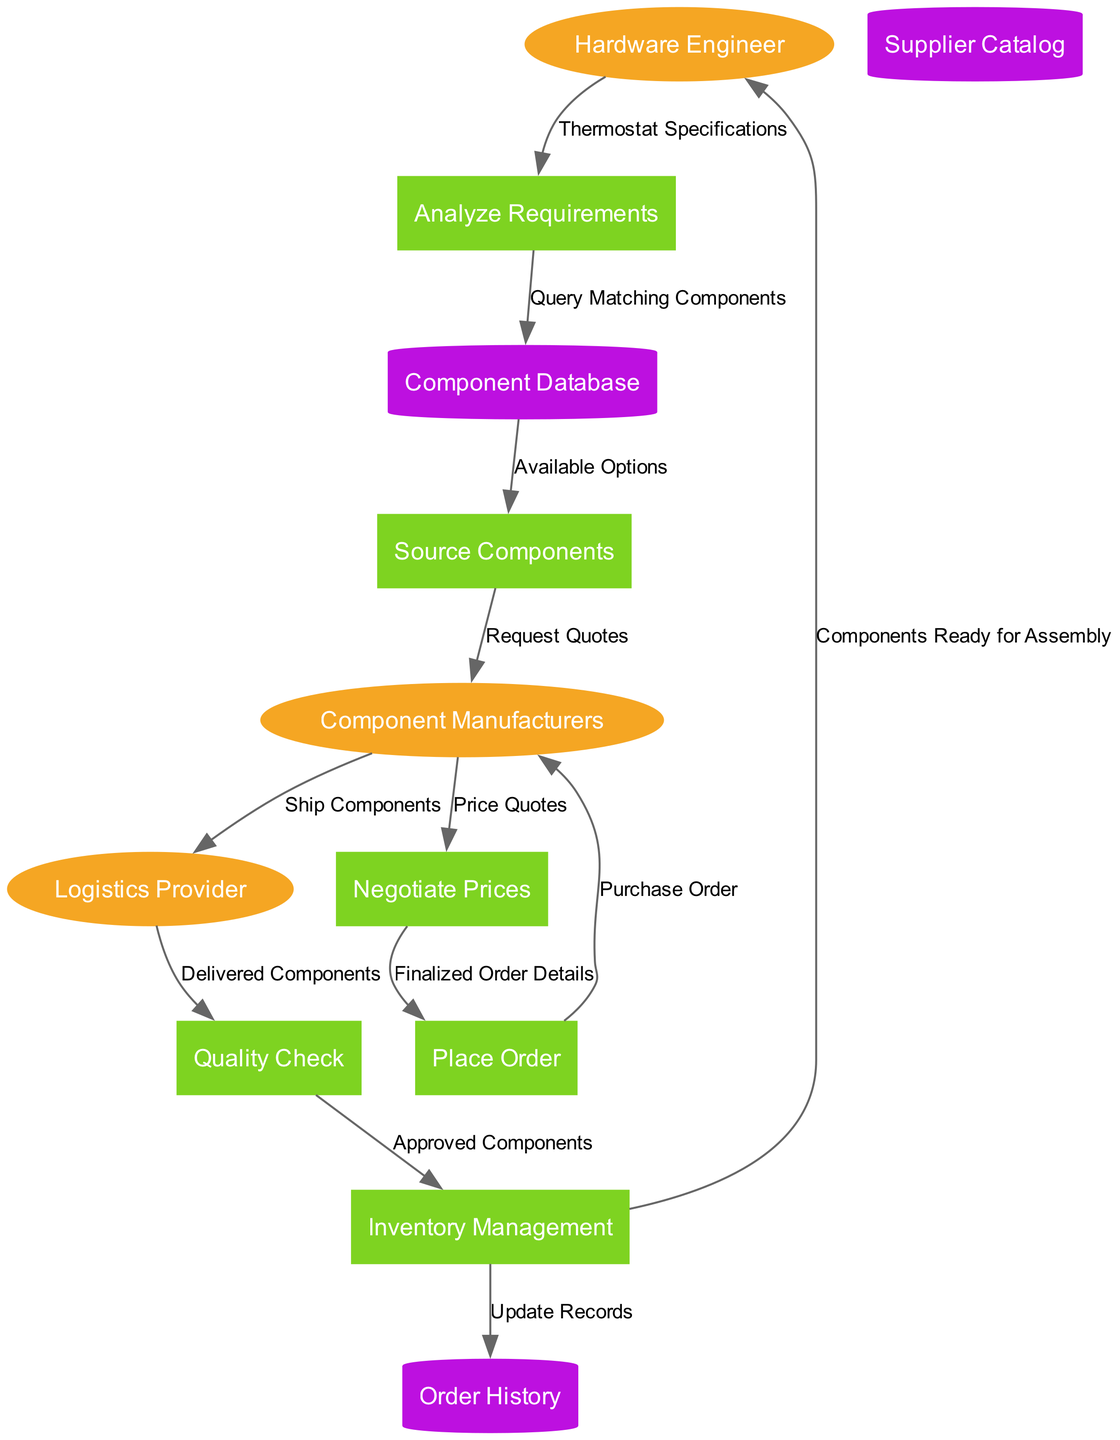What is the first process in the diagram? The first process is where the flow starts, which is indicated by the data coming from the Hardware Engineer for the Thermostat Specifications. This leads to the Analyze Requirements process, which is the first process shown in the diagram.
Answer: Analyze Requirements How many external entities are represented? The diagram shows three external entities: Hardware Engineer, Component Manufacturers, and Logistics Provider. Counting these gives us the total number of external entities.
Answer: 3 What type of data store is used to keep track of past orders? The data store responsible for keeping track of past orders is labeled as Order History. This classification distinguishes it from other types of data stores in the diagram.
Answer: Order History Which process follows the request for quotes from Component Manufacturers? After the Source Components process sends requests for quotes to Component Manufacturers, the next process that receives information from them is Negotiate Prices, which involves handling the Price Quotes received.
Answer: Negotiate Prices What is the data flow between Inventory Management and Hardware Engineer labeled as? The data flow from Inventory Management to Hardware Engineer is labeled as Components Ready for Assembly, indicating what is communicated back to the engineer regarding the status of components.
Answer: Components Ready for Assembly Which external entity is involved in the shipping of components? The external entity that is responsible for shipping the components is the Logistics Provider, as indicated in the flow from Component Manufacturers to Logistics Provider labeled Ship Components.
Answer: Logistics Provider What is the outcome of the Quality Check process? The outcome of the Quality Check process is the Approved Components, which then moves into the next stage of Inventory Management, highlighting its role in the quality assurance of sourced components.
Answer: Approved Components What connects the data store Component Database to the Source Components process? The connection from the Component Database to the Source Components process is through the data flow labeled as Available Options, showing what information is passed along to this process.
Answer: Available Options How does Inventory Management interact with Order History? Inventory Management interacts with Order History by updating records as indicated by the data flow labeled Update Records, ensuring that the history is kept current with the latest component data.
Answer: Update Records 